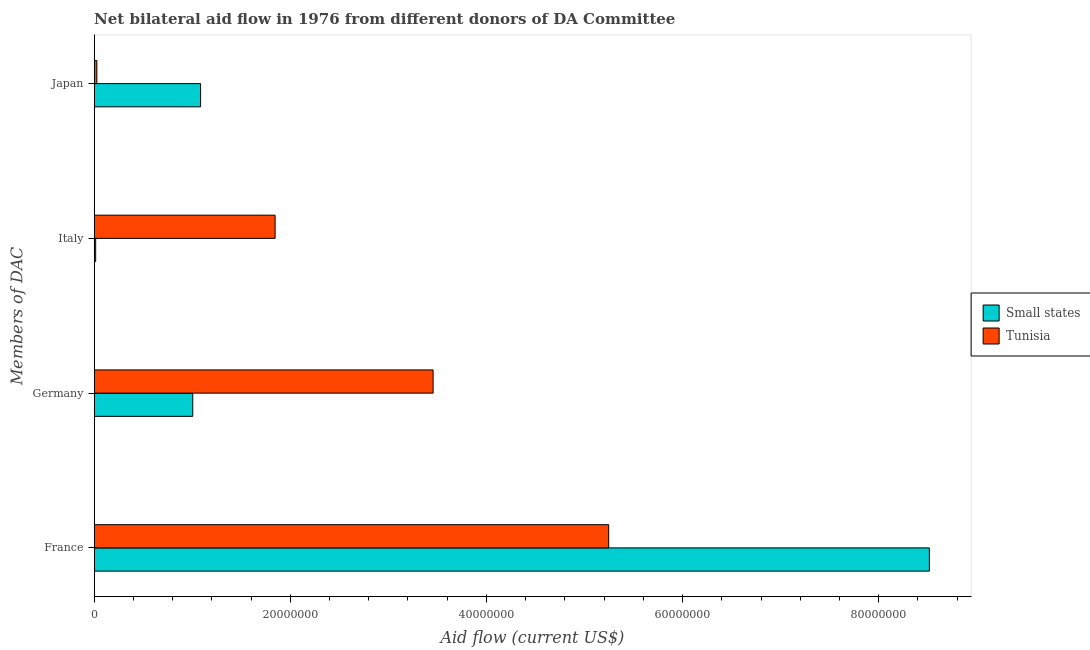How many groups of bars are there?
Your response must be concise. 4. Are the number of bars per tick equal to the number of legend labels?
Your answer should be very brief. Yes. How many bars are there on the 4th tick from the top?
Keep it short and to the point. 2. What is the label of the 1st group of bars from the top?
Offer a terse response. Japan. What is the amount of aid given by italy in Small states?
Give a very brief answer. 1.50e+05. Across all countries, what is the maximum amount of aid given by japan?
Make the answer very short. 1.08e+07. Across all countries, what is the minimum amount of aid given by japan?
Offer a very short reply. 2.70e+05. In which country was the amount of aid given by italy maximum?
Keep it short and to the point. Tunisia. In which country was the amount of aid given by germany minimum?
Offer a terse response. Small states. What is the total amount of aid given by germany in the graph?
Your response must be concise. 4.46e+07. What is the difference between the amount of aid given by italy in Tunisia and that in Small states?
Your answer should be very brief. 1.83e+07. What is the difference between the amount of aid given by germany in Tunisia and the amount of aid given by italy in Small states?
Your answer should be compact. 3.44e+07. What is the average amount of aid given by japan per country?
Your answer should be compact. 5.56e+06. What is the difference between the amount of aid given by japan and amount of aid given by italy in Small states?
Offer a terse response. 1.07e+07. In how many countries, is the amount of aid given by italy greater than 72000000 US$?
Your answer should be compact. 0. What is the ratio of the amount of aid given by france in Tunisia to that in Small states?
Give a very brief answer. 0.62. What is the difference between the highest and the second highest amount of aid given by germany?
Make the answer very short. 2.45e+07. What is the difference between the highest and the lowest amount of aid given by germany?
Provide a short and direct response. 2.45e+07. In how many countries, is the amount of aid given by germany greater than the average amount of aid given by germany taken over all countries?
Provide a short and direct response. 1. Is it the case that in every country, the sum of the amount of aid given by japan and amount of aid given by france is greater than the sum of amount of aid given by italy and amount of aid given by germany?
Offer a very short reply. Yes. What does the 2nd bar from the top in Italy represents?
Give a very brief answer. Small states. What does the 2nd bar from the bottom in France represents?
Keep it short and to the point. Tunisia. What is the difference between two consecutive major ticks on the X-axis?
Ensure brevity in your answer.  2.00e+07. How many legend labels are there?
Offer a terse response. 2. What is the title of the graph?
Ensure brevity in your answer.  Net bilateral aid flow in 1976 from different donors of DA Committee. What is the label or title of the Y-axis?
Your answer should be compact. Members of DAC. What is the Aid flow (current US$) in Small states in France?
Offer a very short reply. 8.52e+07. What is the Aid flow (current US$) of Tunisia in France?
Ensure brevity in your answer.  5.25e+07. What is the Aid flow (current US$) in Small states in Germany?
Your answer should be very brief. 1.00e+07. What is the Aid flow (current US$) in Tunisia in Germany?
Make the answer very short. 3.46e+07. What is the Aid flow (current US$) of Tunisia in Italy?
Give a very brief answer. 1.84e+07. What is the Aid flow (current US$) of Small states in Japan?
Make the answer very short. 1.08e+07. What is the Aid flow (current US$) of Tunisia in Japan?
Provide a short and direct response. 2.70e+05. Across all Members of DAC, what is the maximum Aid flow (current US$) of Small states?
Offer a very short reply. 8.52e+07. Across all Members of DAC, what is the maximum Aid flow (current US$) in Tunisia?
Make the answer very short. 5.25e+07. What is the total Aid flow (current US$) in Small states in the graph?
Provide a succinct answer. 1.06e+08. What is the total Aid flow (current US$) of Tunisia in the graph?
Offer a terse response. 1.06e+08. What is the difference between the Aid flow (current US$) of Small states in France and that in Germany?
Make the answer very short. 7.51e+07. What is the difference between the Aid flow (current US$) in Tunisia in France and that in Germany?
Keep it short and to the point. 1.79e+07. What is the difference between the Aid flow (current US$) in Small states in France and that in Italy?
Your answer should be compact. 8.50e+07. What is the difference between the Aid flow (current US$) in Tunisia in France and that in Italy?
Keep it short and to the point. 3.40e+07. What is the difference between the Aid flow (current US$) of Small states in France and that in Japan?
Keep it short and to the point. 7.43e+07. What is the difference between the Aid flow (current US$) of Tunisia in France and that in Japan?
Your response must be concise. 5.22e+07. What is the difference between the Aid flow (current US$) in Small states in Germany and that in Italy?
Offer a terse response. 9.90e+06. What is the difference between the Aid flow (current US$) of Tunisia in Germany and that in Italy?
Your response must be concise. 1.61e+07. What is the difference between the Aid flow (current US$) in Small states in Germany and that in Japan?
Give a very brief answer. -8.00e+05. What is the difference between the Aid flow (current US$) in Tunisia in Germany and that in Japan?
Keep it short and to the point. 3.43e+07. What is the difference between the Aid flow (current US$) of Small states in Italy and that in Japan?
Offer a very short reply. -1.07e+07. What is the difference between the Aid flow (current US$) in Tunisia in Italy and that in Japan?
Provide a succinct answer. 1.82e+07. What is the difference between the Aid flow (current US$) in Small states in France and the Aid flow (current US$) in Tunisia in Germany?
Provide a succinct answer. 5.06e+07. What is the difference between the Aid flow (current US$) in Small states in France and the Aid flow (current US$) in Tunisia in Italy?
Keep it short and to the point. 6.67e+07. What is the difference between the Aid flow (current US$) of Small states in France and the Aid flow (current US$) of Tunisia in Japan?
Keep it short and to the point. 8.49e+07. What is the difference between the Aid flow (current US$) in Small states in Germany and the Aid flow (current US$) in Tunisia in Italy?
Give a very brief answer. -8.40e+06. What is the difference between the Aid flow (current US$) of Small states in Germany and the Aid flow (current US$) of Tunisia in Japan?
Offer a very short reply. 9.78e+06. What is the difference between the Aid flow (current US$) in Small states in Italy and the Aid flow (current US$) in Tunisia in Japan?
Make the answer very short. -1.20e+05. What is the average Aid flow (current US$) of Small states per Members of DAC?
Offer a very short reply. 2.66e+07. What is the average Aid flow (current US$) of Tunisia per Members of DAC?
Provide a short and direct response. 2.64e+07. What is the difference between the Aid flow (current US$) in Small states and Aid flow (current US$) in Tunisia in France?
Your answer should be compact. 3.27e+07. What is the difference between the Aid flow (current US$) of Small states and Aid flow (current US$) of Tunisia in Germany?
Give a very brief answer. -2.45e+07. What is the difference between the Aid flow (current US$) of Small states and Aid flow (current US$) of Tunisia in Italy?
Provide a succinct answer. -1.83e+07. What is the difference between the Aid flow (current US$) in Small states and Aid flow (current US$) in Tunisia in Japan?
Offer a very short reply. 1.06e+07. What is the ratio of the Aid flow (current US$) of Small states in France to that in Germany?
Provide a short and direct response. 8.47. What is the ratio of the Aid flow (current US$) in Tunisia in France to that in Germany?
Provide a short and direct response. 1.52. What is the ratio of the Aid flow (current US$) in Small states in France to that in Italy?
Make the answer very short. 567.8. What is the ratio of the Aid flow (current US$) in Tunisia in France to that in Italy?
Make the answer very short. 2.84. What is the ratio of the Aid flow (current US$) in Small states in France to that in Japan?
Ensure brevity in your answer.  7.85. What is the ratio of the Aid flow (current US$) in Tunisia in France to that in Japan?
Make the answer very short. 194.33. What is the ratio of the Aid flow (current US$) of Small states in Germany to that in Italy?
Provide a succinct answer. 67. What is the ratio of the Aid flow (current US$) in Tunisia in Germany to that in Italy?
Ensure brevity in your answer.  1.87. What is the ratio of the Aid flow (current US$) of Small states in Germany to that in Japan?
Ensure brevity in your answer.  0.93. What is the ratio of the Aid flow (current US$) of Tunisia in Germany to that in Japan?
Give a very brief answer. 128. What is the ratio of the Aid flow (current US$) of Small states in Italy to that in Japan?
Provide a short and direct response. 0.01. What is the ratio of the Aid flow (current US$) in Tunisia in Italy to that in Japan?
Ensure brevity in your answer.  68.33. What is the difference between the highest and the second highest Aid flow (current US$) of Small states?
Your response must be concise. 7.43e+07. What is the difference between the highest and the second highest Aid flow (current US$) in Tunisia?
Your answer should be very brief. 1.79e+07. What is the difference between the highest and the lowest Aid flow (current US$) of Small states?
Ensure brevity in your answer.  8.50e+07. What is the difference between the highest and the lowest Aid flow (current US$) of Tunisia?
Your answer should be very brief. 5.22e+07. 